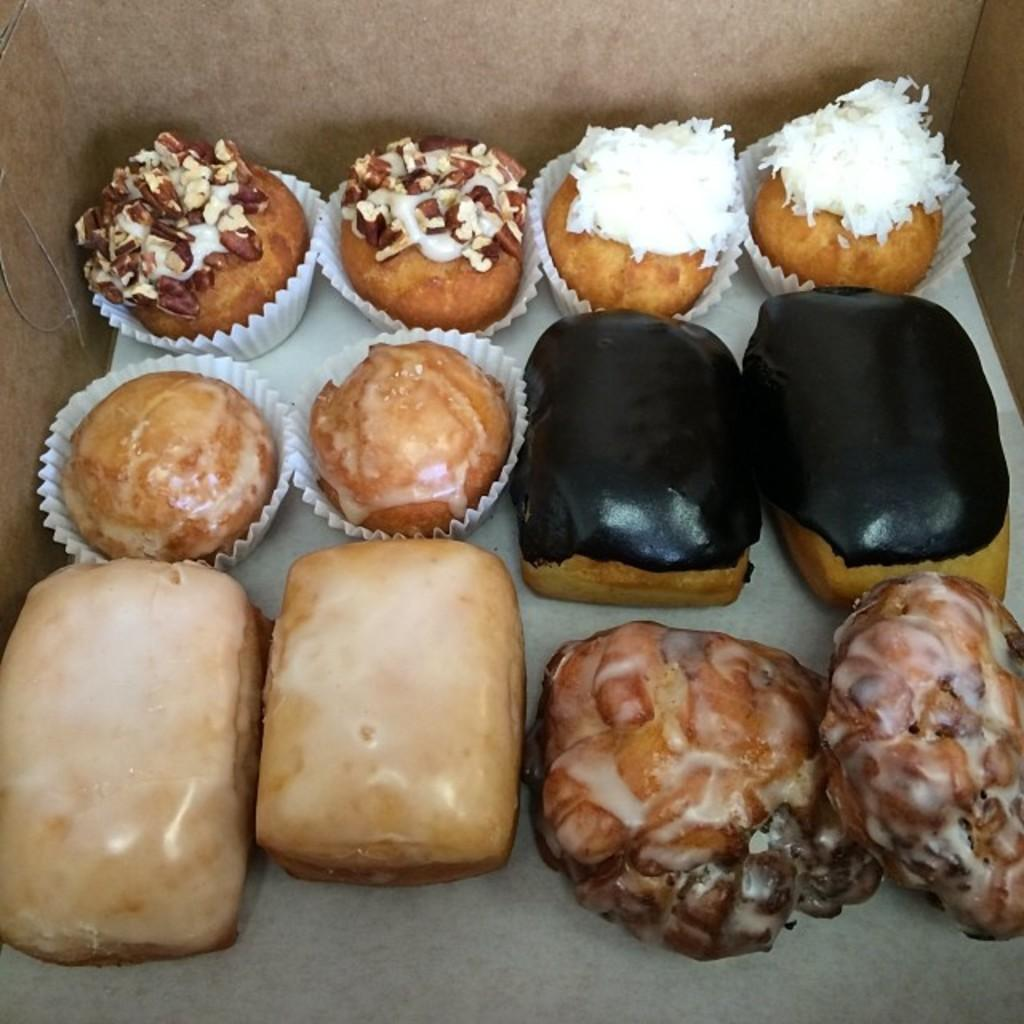What type of desserts can be seen in the image? There are cakes and donuts in the image. Where are the cakes and donuts located in the image? The cakes and donuts are placed in the center of the image. What type of poison can be seen on the cakes in the image? There is no poison present on the cakes in the image. Can you tell me how many deer are visible in the image? There are no deer present in the image. 